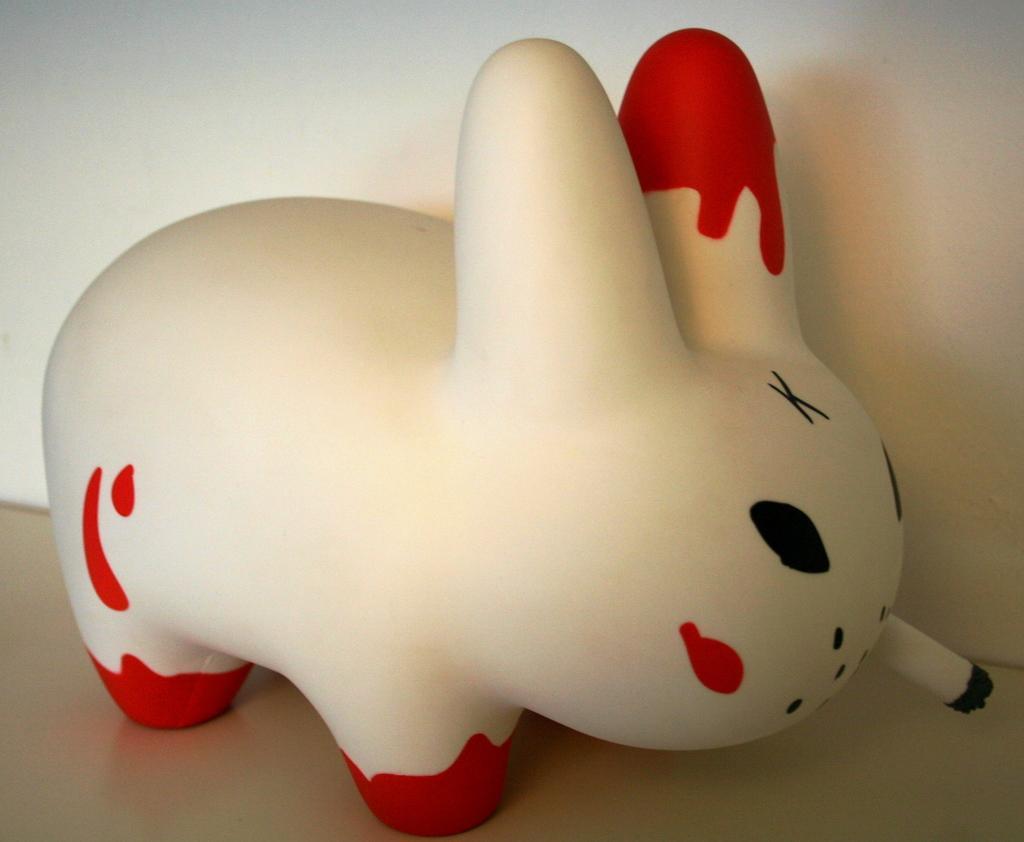Please provide a concise description of this image. In this image I can see a doll, it is in white and red color. 